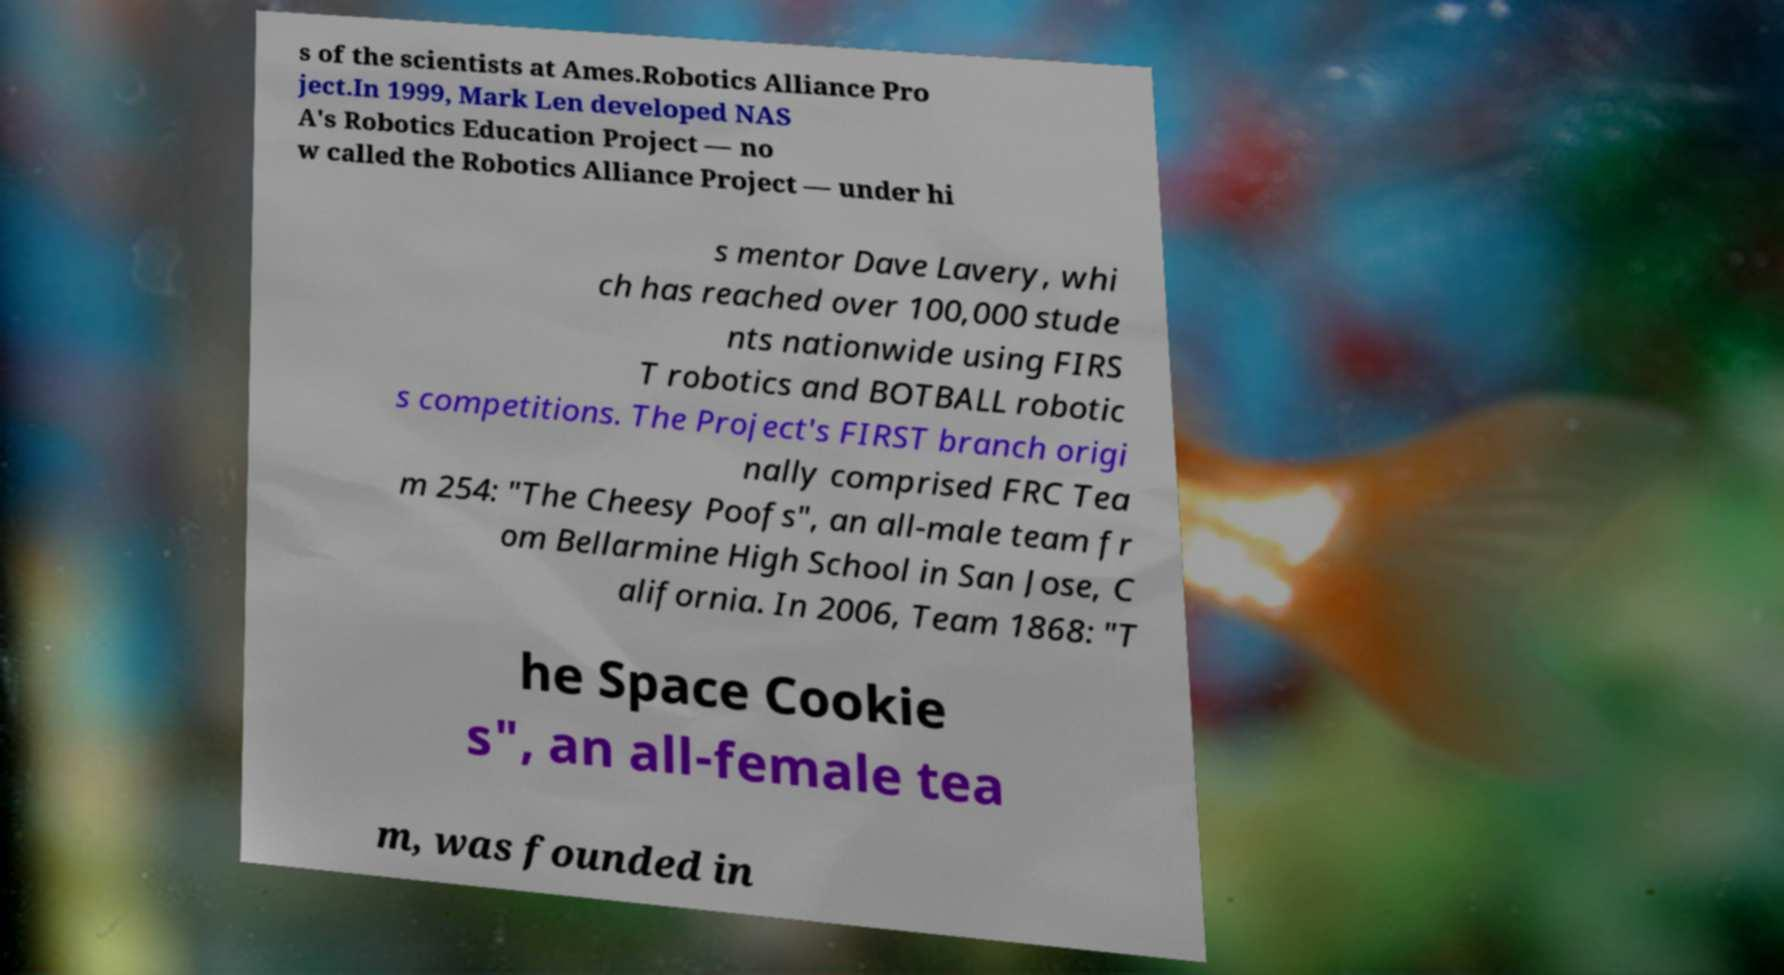Could you extract and type out the text from this image? s of the scientists at Ames.Robotics Alliance Pro ject.In 1999, Mark Len developed NAS A's Robotics Education Project — no w called the Robotics Alliance Project — under hi s mentor Dave Lavery, whi ch has reached over 100,000 stude nts nationwide using FIRS T robotics and BOTBALL robotic s competitions. The Project's FIRST branch origi nally comprised FRC Tea m 254: "The Cheesy Poofs", an all-male team fr om Bellarmine High School in San Jose, C alifornia. In 2006, Team 1868: "T he Space Cookie s", an all-female tea m, was founded in 